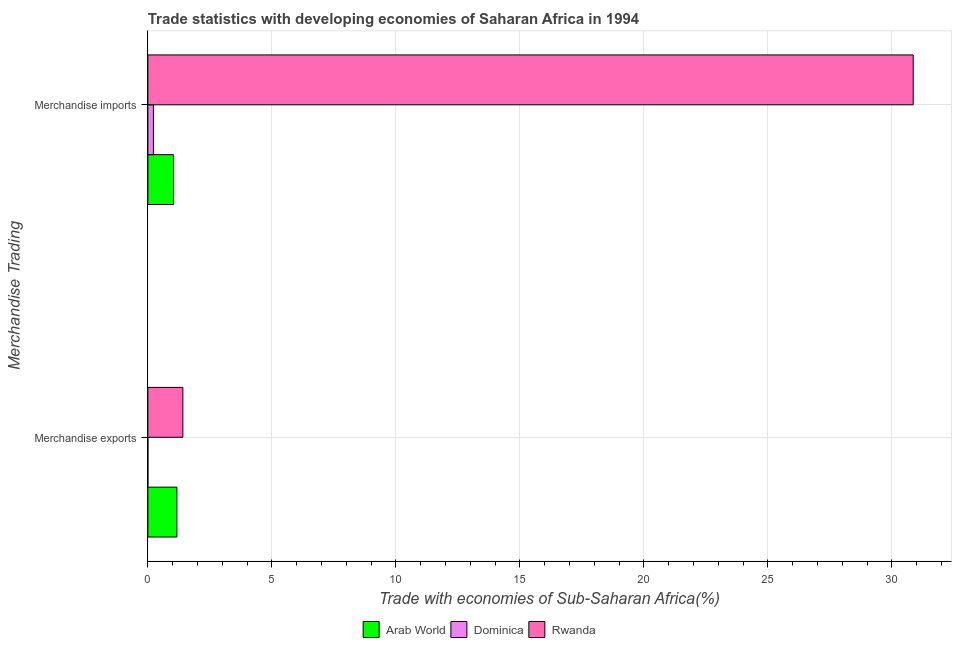How many groups of bars are there?
Offer a very short reply. 2. Are the number of bars per tick equal to the number of legend labels?
Make the answer very short. Yes. How many bars are there on the 1st tick from the bottom?
Your response must be concise. 3. What is the merchandise exports in Dominica?
Make the answer very short. 0. Across all countries, what is the maximum merchandise imports?
Your answer should be very brief. 30.86. Across all countries, what is the minimum merchandise exports?
Provide a short and direct response. 0. In which country was the merchandise imports maximum?
Your response must be concise. Rwanda. In which country was the merchandise exports minimum?
Provide a succinct answer. Dominica. What is the total merchandise imports in the graph?
Keep it short and to the point. 32.12. What is the difference between the merchandise exports in Dominica and that in Rwanda?
Your answer should be compact. -1.41. What is the difference between the merchandise exports in Dominica and the merchandise imports in Rwanda?
Offer a terse response. -30.86. What is the average merchandise exports per country?
Provide a succinct answer. 0.86. What is the difference between the merchandise imports and merchandise exports in Dominica?
Give a very brief answer. 0.22. What is the ratio of the merchandise exports in Dominica to that in Rwanda?
Provide a short and direct response. 0. Is the merchandise exports in Arab World less than that in Rwanda?
Ensure brevity in your answer.  Yes. What does the 3rd bar from the top in Merchandise imports represents?
Your answer should be compact. Arab World. What does the 1st bar from the bottom in Merchandise imports represents?
Provide a short and direct response. Arab World. Are all the bars in the graph horizontal?
Provide a succinct answer. Yes. Are the values on the major ticks of X-axis written in scientific E-notation?
Offer a terse response. No. Does the graph contain any zero values?
Ensure brevity in your answer.  No. Does the graph contain grids?
Provide a short and direct response. Yes. Where does the legend appear in the graph?
Provide a short and direct response. Bottom center. How are the legend labels stacked?
Your answer should be compact. Horizontal. What is the title of the graph?
Ensure brevity in your answer.  Trade statistics with developing economies of Saharan Africa in 1994. Does "Fragile and conflict affected situations" appear as one of the legend labels in the graph?
Your response must be concise. No. What is the label or title of the X-axis?
Offer a terse response. Trade with economies of Sub-Saharan Africa(%). What is the label or title of the Y-axis?
Offer a very short reply. Merchandise Trading. What is the Trade with economies of Sub-Saharan Africa(%) of Arab World in Merchandise exports?
Ensure brevity in your answer.  1.17. What is the Trade with economies of Sub-Saharan Africa(%) of Dominica in Merchandise exports?
Offer a very short reply. 0. What is the Trade with economies of Sub-Saharan Africa(%) in Rwanda in Merchandise exports?
Ensure brevity in your answer.  1.41. What is the Trade with economies of Sub-Saharan Africa(%) in Arab World in Merchandise imports?
Provide a succinct answer. 1.03. What is the Trade with economies of Sub-Saharan Africa(%) of Dominica in Merchandise imports?
Offer a terse response. 0.22. What is the Trade with economies of Sub-Saharan Africa(%) of Rwanda in Merchandise imports?
Keep it short and to the point. 30.86. Across all Merchandise Trading, what is the maximum Trade with economies of Sub-Saharan Africa(%) in Arab World?
Ensure brevity in your answer.  1.17. Across all Merchandise Trading, what is the maximum Trade with economies of Sub-Saharan Africa(%) of Dominica?
Keep it short and to the point. 0.22. Across all Merchandise Trading, what is the maximum Trade with economies of Sub-Saharan Africa(%) of Rwanda?
Provide a short and direct response. 30.86. Across all Merchandise Trading, what is the minimum Trade with economies of Sub-Saharan Africa(%) in Arab World?
Give a very brief answer. 1.03. Across all Merchandise Trading, what is the minimum Trade with economies of Sub-Saharan Africa(%) of Dominica?
Your answer should be very brief. 0. Across all Merchandise Trading, what is the minimum Trade with economies of Sub-Saharan Africa(%) in Rwanda?
Provide a short and direct response. 1.41. What is the total Trade with economies of Sub-Saharan Africa(%) in Arab World in the graph?
Your response must be concise. 2.2. What is the total Trade with economies of Sub-Saharan Africa(%) of Dominica in the graph?
Provide a succinct answer. 0.22. What is the total Trade with economies of Sub-Saharan Africa(%) in Rwanda in the graph?
Keep it short and to the point. 32.27. What is the difference between the Trade with economies of Sub-Saharan Africa(%) of Arab World in Merchandise exports and that in Merchandise imports?
Offer a terse response. 0.14. What is the difference between the Trade with economies of Sub-Saharan Africa(%) in Dominica in Merchandise exports and that in Merchandise imports?
Provide a short and direct response. -0.22. What is the difference between the Trade with economies of Sub-Saharan Africa(%) of Rwanda in Merchandise exports and that in Merchandise imports?
Keep it short and to the point. -29.45. What is the difference between the Trade with economies of Sub-Saharan Africa(%) of Arab World in Merchandise exports and the Trade with economies of Sub-Saharan Africa(%) of Dominica in Merchandise imports?
Offer a terse response. 0.95. What is the difference between the Trade with economies of Sub-Saharan Africa(%) of Arab World in Merchandise exports and the Trade with economies of Sub-Saharan Africa(%) of Rwanda in Merchandise imports?
Give a very brief answer. -29.69. What is the difference between the Trade with economies of Sub-Saharan Africa(%) in Dominica in Merchandise exports and the Trade with economies of Sub-Saharan Africa(%) in Rwanda in Merchandise imports?
Make the answer very short. -30.86. What is the average Trade with economies of Sub-Saharan Africa(%) of Arab World per Merchandise Trading?
Provide a succinct answer. 1.1. What is the average Trade with economies of Sub-Saharan Africa(%) of Dominica per Merchandise Trading?
Ensure brevity in your answer.  0.11. What is the average Trade with economies of Sub-Saharan Africa(%) of Rwanda per Merchandise Trading?
Provide a succinct answer. 16.14. What is the difference between the Trade with economies of Sub-Saharan Africa(%) in Arab World and Trade with economies of Sub-Saharan Africa(%) in Dominica in Merchandise exports?
Your response must be concise. 1.17. What is the difference between the Trade with economies of Sub-Saharan Africa(%) of Arab World and Trade with economies of Sub-Saharan Africa(%) of Rwanda in Merchandise exports?
Your response must be concise. -0.24. What is the difference between the Trade with economies of Sub-Saharan Africa(%) of Dominica and Trade with economies of Sub-Saharan Africa(%) of Rwanda in Merchandise exports?
Provide a short and direct response. -1.41. What is the difference between the Trade with economies of Sub-Saharan Africa(%) of Arab World and Trade with economies of Sub-Saharan Africa(%) of Dominica in Merchandise imports?
Make the answer very short. 0.81. What is the difference between the Trade with economies of Sub-Saharan Africa(%) in Arab World and Trade with economies of Sub-Saharan Africa(%) in Rwanda in Merchandise imports?
Your response must be concise. -29.83. What is the difference between the Trade with economies of Sub-Saharan Africa(%) in Dominica and Trade with economies of Sub-Saharan Africa(%) in Rwanda in Merchandise imports?
Offer a very short reply. -30.64. What is the ratio of the Trade with economies of Sub-Saharan Africa(%) of Arab World in Merchandise exports to that in Merchandise imports?
Your answer should be compact. 1.13. What is the ratio of the Trade with economies of Sub-Saharan Africa(%) in Dominica in Merchandise exports to that in Merchandise imports?
Offer a very short reply. 0. What is the ratio of the Trade with economies of Sub-Saharan Africa(%) in Rwanda in Merchandise exports to that in Merchandise imports?
Make the answer very short. 0.05. What is the difference between the highest and the second highest Trade with economies of Sub-Saharan Africa(%) of Arab World?
Provide a succinct answer. 0.14. What is the difference between the highest and the second highest Trade with economies of Sub-Saharan Africa(%) of Dominica?
Provide a succinct answer. 0.22. What is the difference between the highest and the second highest Trade with economies of Sub-Saharan Africa(%) of Rwanda?
Make the answer very short. 29.45. What is the difference between the highest and the lowest Trade with economies of Sub-Saharan Africa(%) of Arab World?
Provide a short and direct response. 0.14. What is the difference between the highest and the lowest Trade with economies of Sub-Saharan Africa(%) in Dominica?
Provide a succinct answer. 0.22. What is the difference between the highest and the lowest Trade with economies of Sub-Saharan Africa(%) in Rwanda?
Keep it short and to the point. 29.45. 